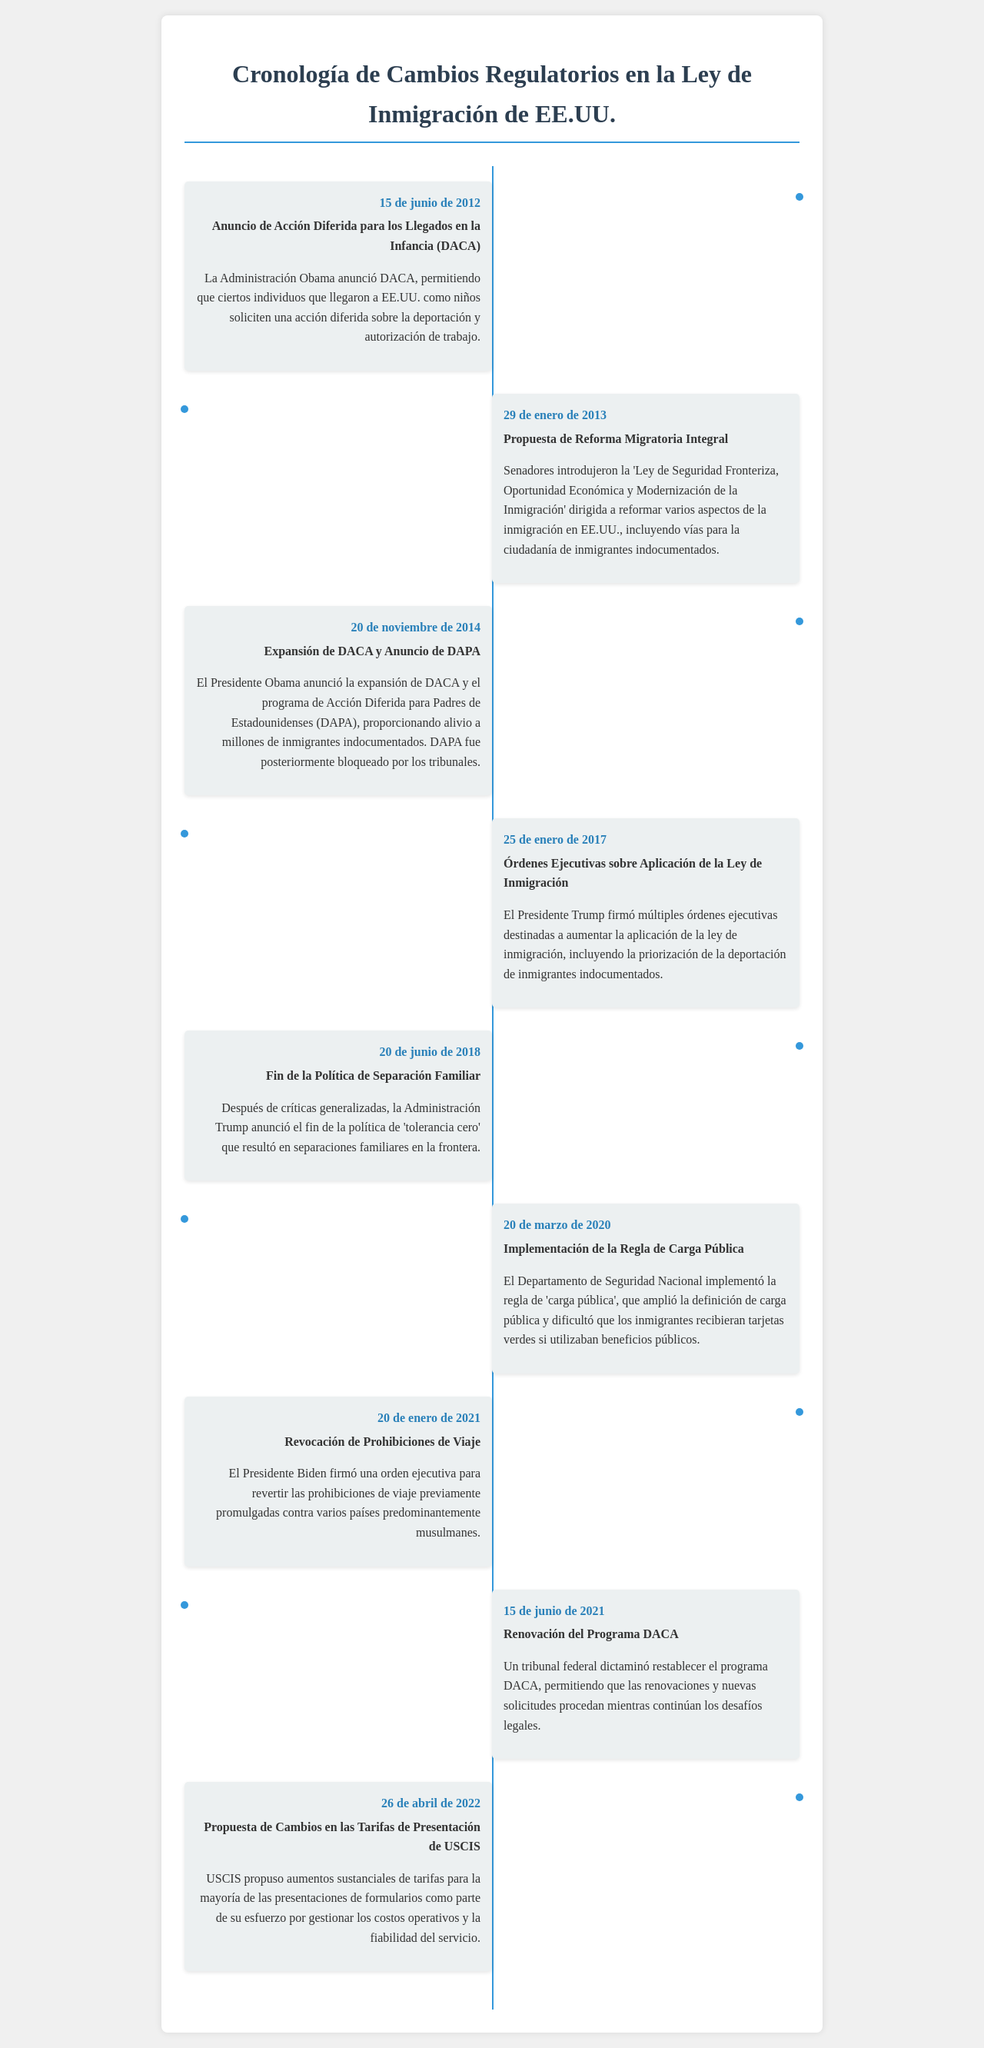¿Qué evento fue anunciado el 15 de junio de 2012? El evento anunciado fue la Acción Diferida para los Llegados en la Infancia (DACA), que permite que ciertos individuos que llegaron a EE.UU. como niños soliciten una acción diferida sobre la deportación.
Answer: DACA ¿Cuál fue la propuesta de los senadores el 29 de enero de 2013? Se introdujo la 'Ley de Seguridad Fronteriza, Oportunidad Económica y Modernización de la Inmigración', dirigida a reformar varios aspectos de la inmigración en EE.UU.
Answer: Reforma Migratoria Integral ¿Qué programa fue anunciado el 20 de noviembre de 2014? El programa anunciado fue la expansión de DACA y el DAPA (Acción Diferida para Padres de Estadounidenses).
Answer: DAPA ¿Qué política fue finalizada el 20 de junio de 2018? Se anunció el fin de la política de separación familiar, que había resultado en separaciones en la frontera.
Answer: Política de Separación Familiar ¿Cuál fue la fecha de implementación de la regla de carga pública? La regla de carga pública fue implementada el 20 de marzo de 2020 por el Departamento de Seguridad Nacional.
Answer: 20 de marzo de 2020 ¿Cuándo se revocaron las prohibiciones de viaje impuestas anteriormente? Las prohibiciones de viaje fueron revocadas el 20 de enero de 2021 por el Presidente Biden.
Answer: 20 de enero de 2021 ¿Qué tribunal dictaminó sobre el programa DACA el 15 de junio de 2021? Un tribunal federal dictaminó restablecer el programa DACA, permitiendo renovaciones y nuevas solicitudes.
Answer: Tribunal Federal ¿Cuál fue uno de los objetivos de USCIS el 26 de abril de 2022? USCIS propuso aumentos sustanciales de tarifas para la mayoría de las presentaciones de formularios.
Answer: Aumento de tarifas ¿Qué presidente emitió órdenes ejecutivas el 25 de enero de 2017? El Presidente Trump fue quien firmó múltiples órdenes ejecutivas sobre la aplicación de la ley de inmigración.
Answer: Presidente Trump 